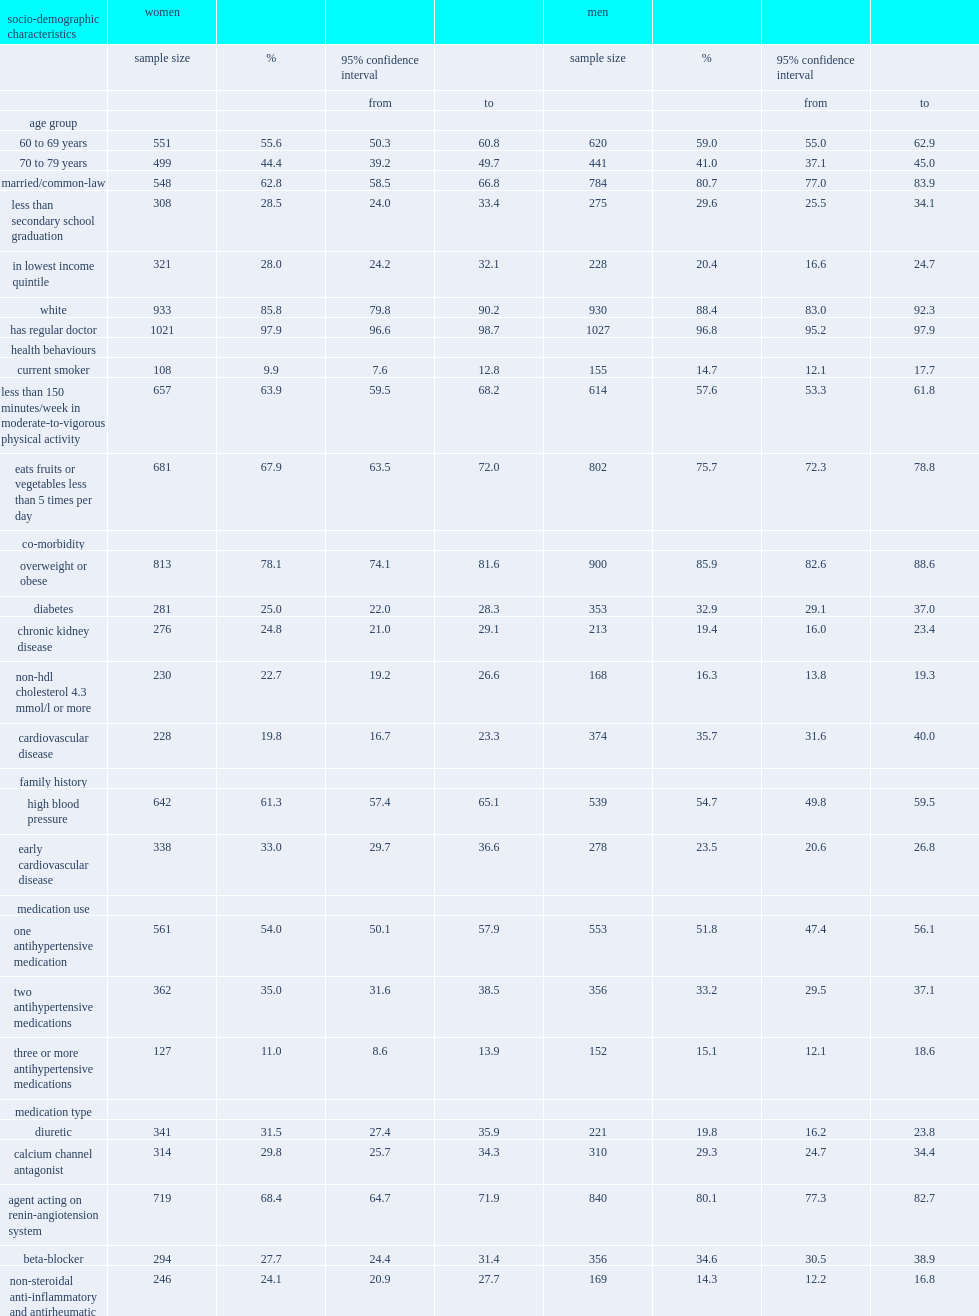List all the risk factors that women treated for hypertension has less than treated men. Married/common-law. List all the risk factors that women treated for hypertensionthan has more than men treated for hypertensionthan. Less than 150 minutes/week in moderate-to-vigorous physical activity. What types of medication were women treated for hypertension more likely to report using than treated men? Diuretic. What types of medication were women treated for hypertension less likely to report using than treated men? Agent acting on renin-angiotension system beta-blocker. 